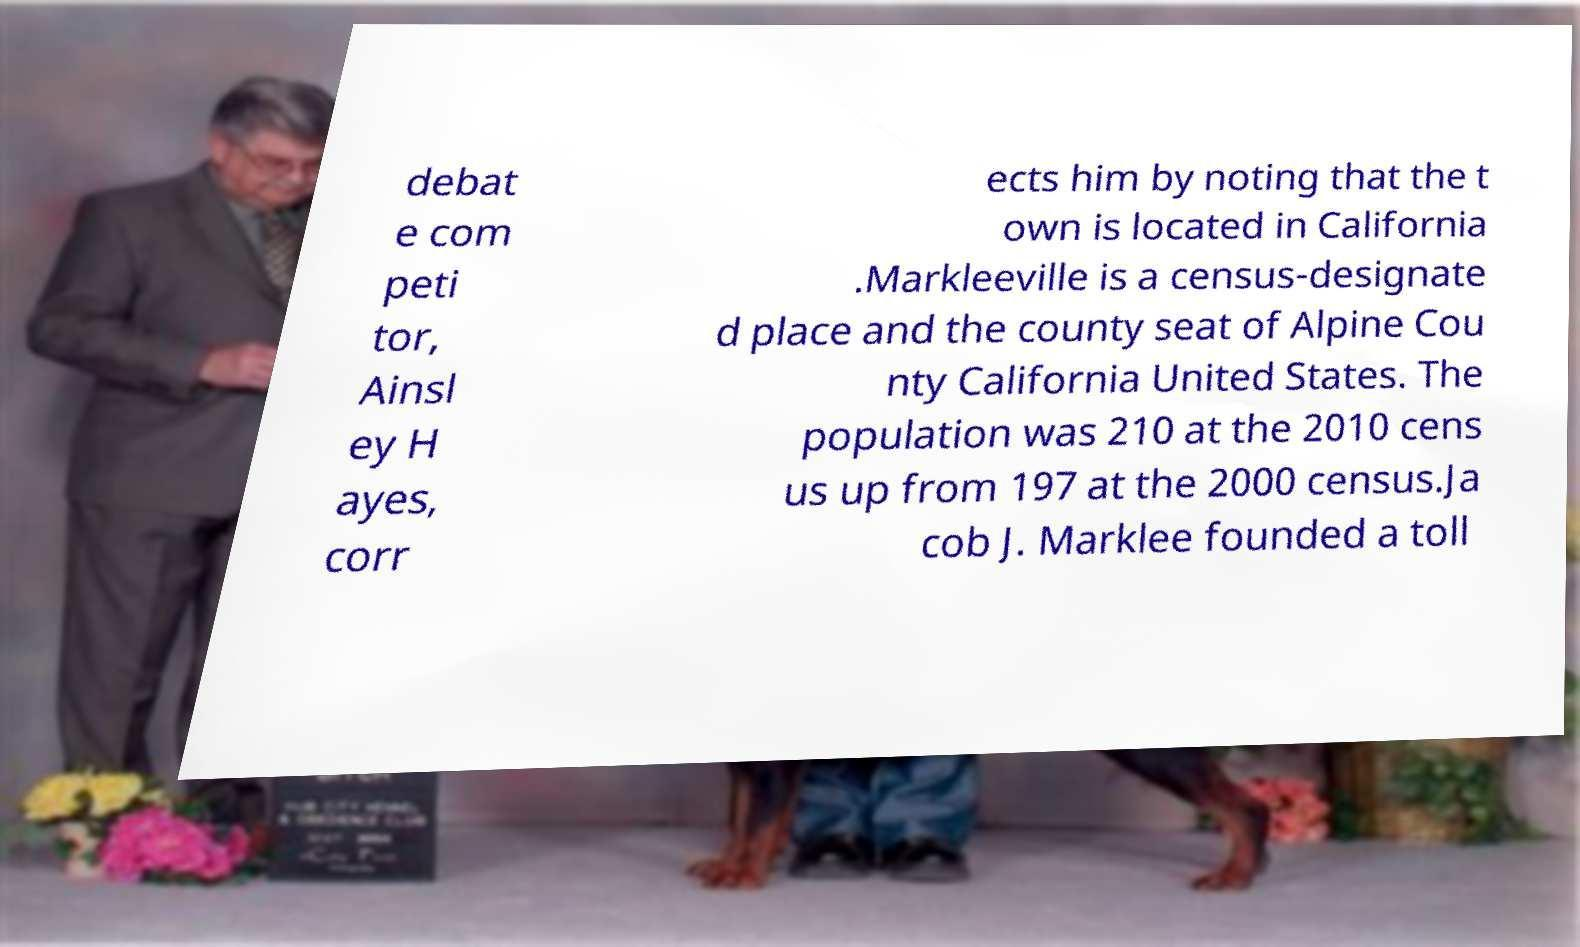What messages or text are displayed in this image? I need them in a readable, typed format. debat e com peti tor, Ainsl ey H ayes, corr ects him by noting that the t own is located in California .Markleeville is a census-designate d place and the county seat of Alpine Cou nty California United States. The population was 210 at the 2010 cens us up from 197 at the 2000 census.Ja cob J. Marklee founded a toll 